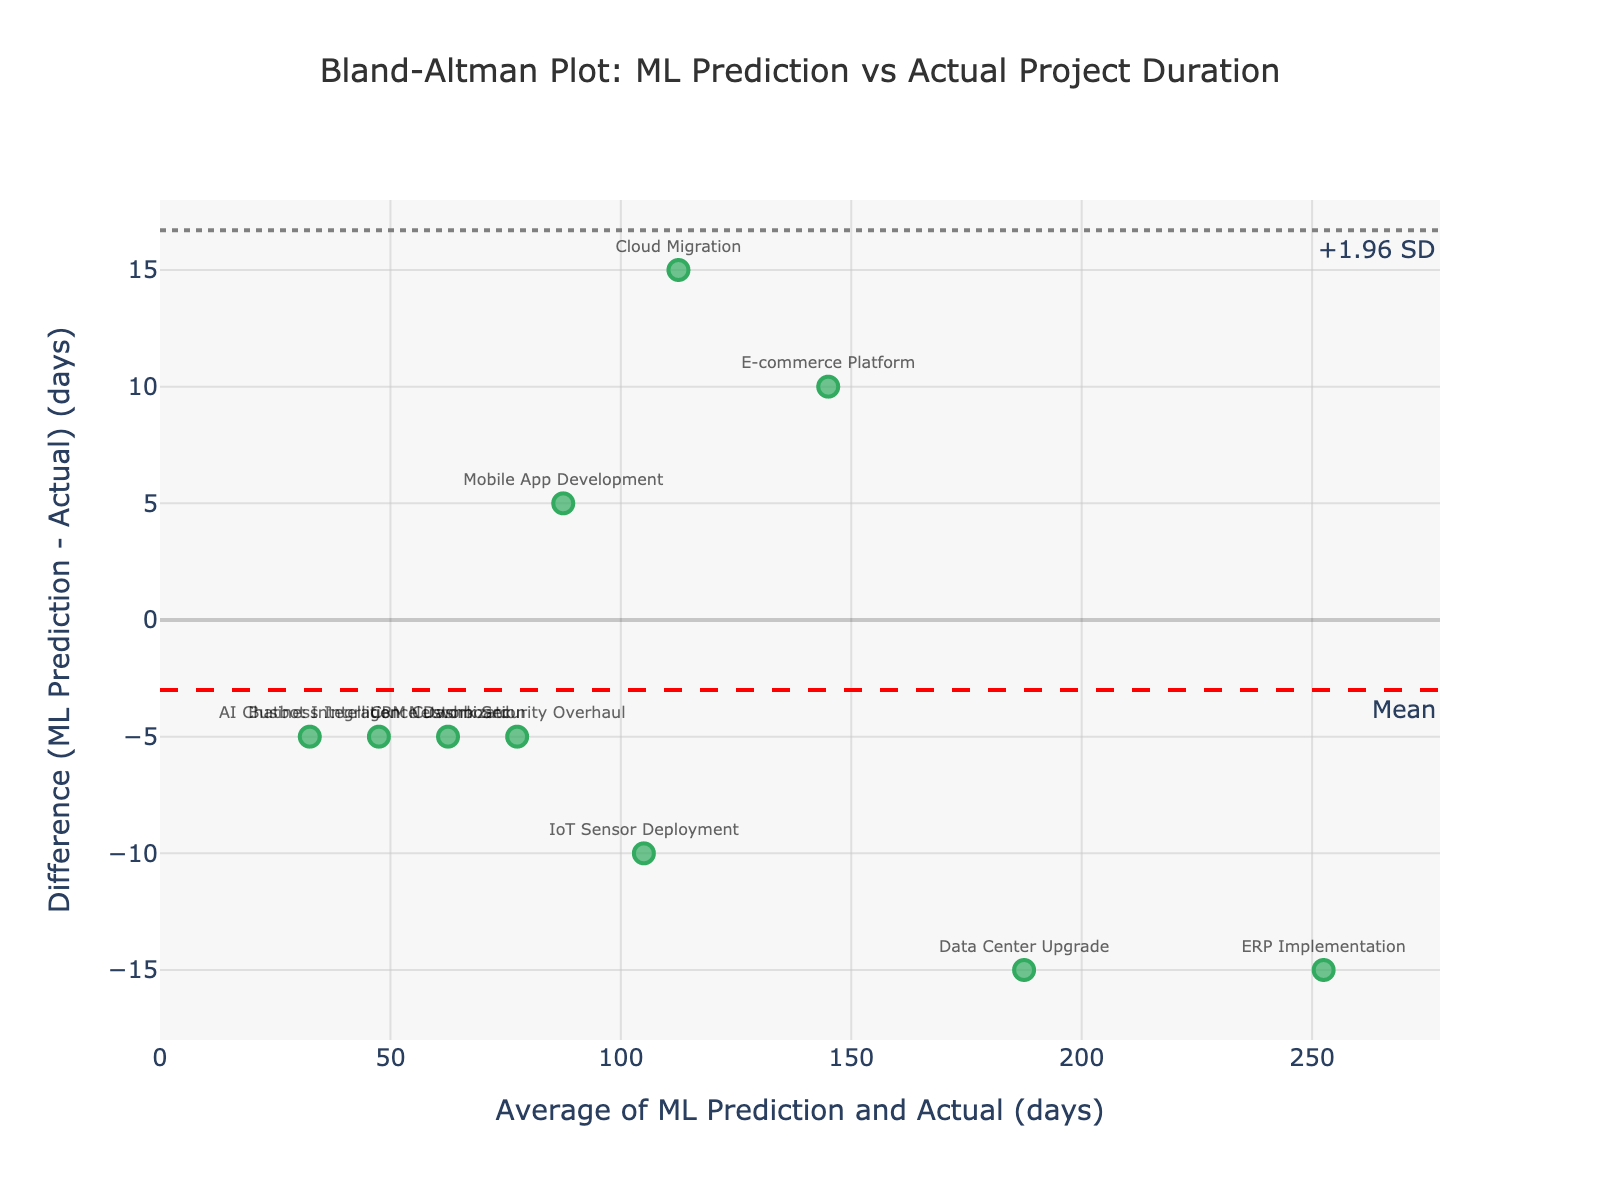What is the title of the plot? The title of the plot is provided at the top center of the figure. It states "Bland-Altman Plot: ML Prediction vs Actual Project Duration".
Answer: Bland-Altman Plot: ML Prediction vs Actual Project Duration How many projects are represented in the plot? To determine the number of projects, count the number of marker points on the plot. Each marker represents one project. There are 10 markers.
Answer: 10 What does the y-axis represent? The y-axis represents the difference between the machine learning prediction days and the actual project days (ML Prediction - Actual) in days. This is directly stated by the y-axis label.
Answer: Difference (ML Prediction - Actual) (days) Which project has the largest positive difference between ML prediction and actual duration? To determine this, look at the highest point on the y-axis. The highest point corresponds to the project "Cloud Migration", which has the largest positive difference.
Answer: Cloud Migration What are the limits of agreement for the differences? The limits of agreement are marked by the dashed lines on the plot. The upper limit is labeled "+1.96 SD" and the lower limit is labeled "-1.96 SD". These indicate approximately 39.12 and -34.32, respectively.
Answer: +1.96 SD: 39.12, -1.96 SD: -34.32 What is the mean difference between the ML predictions and actual project durations? The mean difference is shown by the horizontal dashed red line on the plot, which is labeled "Mean". The mean difference is approximately 2.40 days.
Answer: 2.40 Which projects have differences outside the limits of agreement? Projects outside the limits of agreement will have points above or below the dashed gray lines. There are no points outside these lines, so no projects have differences outside the limits of agreement.
Answer: None Which project has the smallest average of ML prediction and actual duration? To find this, look at the point closest to the left on the x-axis. The project "AI Chatbot Integration" has the smallest average duration of approximately 32.5 days.
Answer: AI Chatbot Integration How does the difference for "ERP Implementation" compare to the mean difference? The "ERP Implementation" project's difference is slightly above the 0-line on the y-axis, indicating it's above the mean difference. By observing its position, it's approximately equal to the mean difference of 2.40, indicating it aligns closely with the average difference.
Answer: Slightly above the mean difference What can be interpreted from the majority of the points being between the limits of agreement? The fact that most of the points fall between the limits of agreement (approximately +1.96 SD and -1.96 SD) indicates that the majority of ML model predictions are reasonably close to the actual durations, with a random error present. This suggests that the model is generally reliable within a certain margin of error.
Answer: The model is generally reliable 